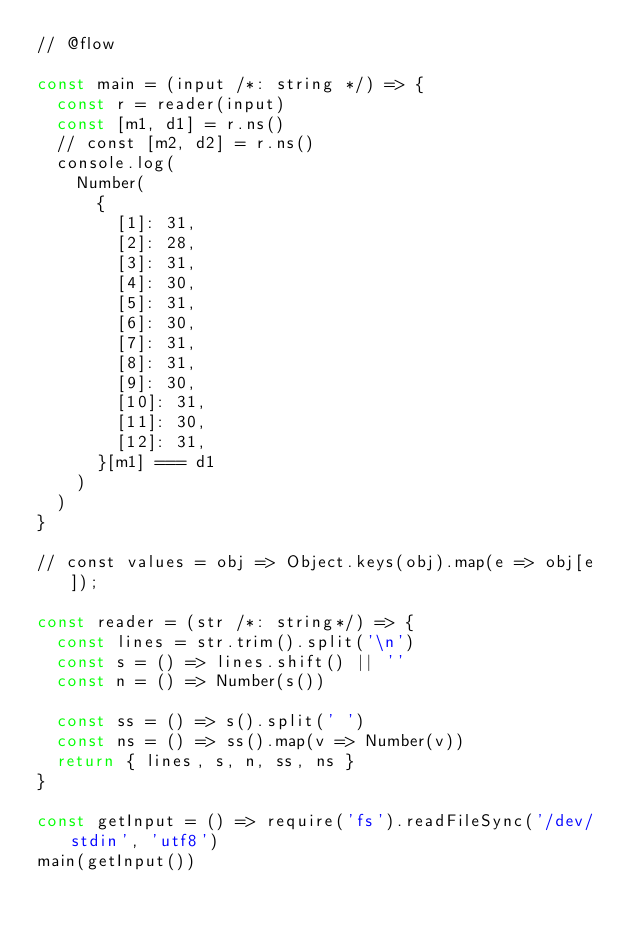Convert code to text. <code><loc_0><loc_0><loc_500><loc_500><_JavaScript_>// @flow

const main = (input /*: string */) => {
  const r = reader(input)
  const [m1, d1] = r.ns()
  // const [m2, d2] = r.ns()
  console.log(
    Number(
      {
        [1]: 31,
        [2]: 28,
        [3]: 31,
        [4]: 30,
        [5]: 31,
        [6]: 30,
        [7]: 31,
        [8]: 31,
        [9]: 30,
        [10]: 31,
        [11]: 30,
        [12]: 31,
      }[m1] === d1
    )
  )
}

// const values = obj => Object.keys(obj).map(e => obj[e]);

const reader = (str /*: string*/) => {
  const lines = str.trim().split('\n')
  const s = () => lines.shift() || ''
  const n = () => Number(s())

  const ss = () => s().split(' ')
  const ns = () => ss().map(v => Number(v))
  return { lines, s, n, ss, ns }
}

const getInput = () => require('fs').readFileSync('/dev/stdin', 'utf8')
main(getInput())
</code> 